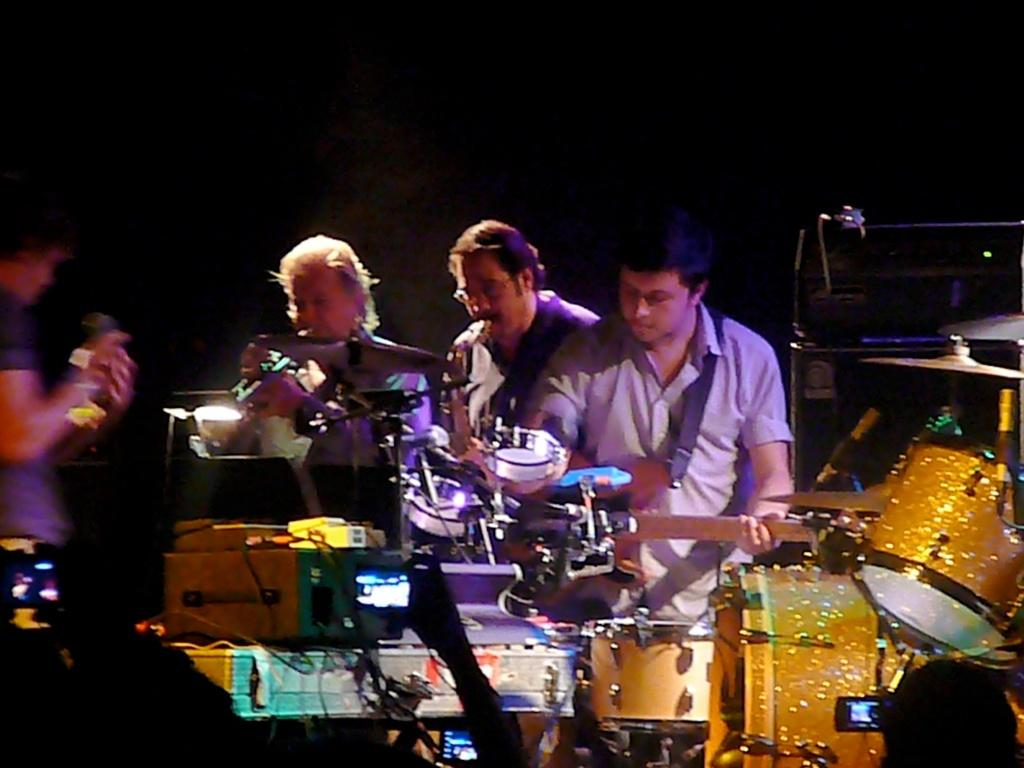What are the people in the image doing? The people in the image are playing musical instruments. Can you describe the background of the image? There is a dark shade in the background of the image. What type of neck can be seen on the person playing the guitar in the image? There is no specific neck visible on the person playing the guitar in the image. What meal is being prepared in the background of the image? There is no meal preparation visible in the image; it only features people playing musical instruments and a dark background. 